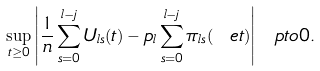Convert formula to latex. <formula><loc_0><loc_0><loc_500><loc_500>\sup _ { t \geq 0 } \left | \frac { 1 } { n } \sum _ { s = 0 } ^ { l - j } U _ { l s } ( t ) - p _ { l } \sum _ { s = 0 } ^ { l - j } \pi _ { l s } ( \ e t ) \right | \ p t o 0 .</formula> 